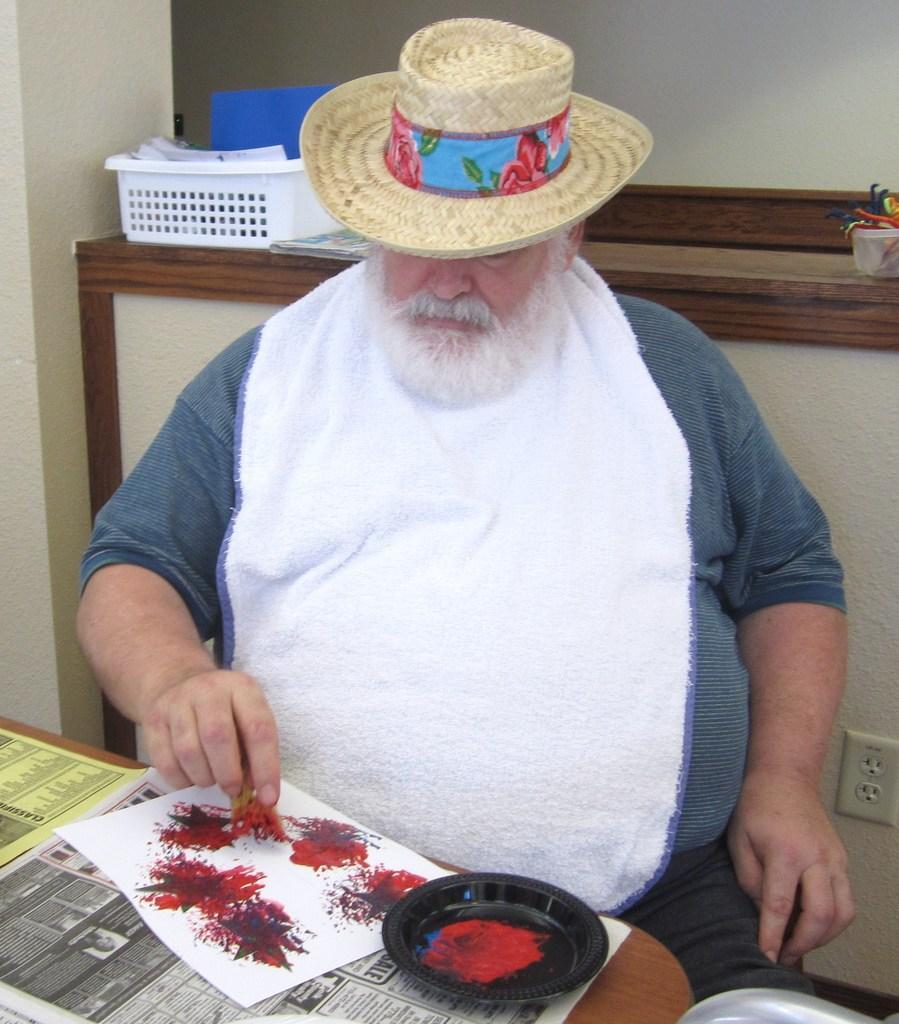Describe this image in one or two sentences. A man is standing wearing hat. This is tray, paper, plate. 